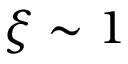Convert formula to latex. <formula><loc_0><loc_0><loc_500><loc_500>\xi \sim 1</formula> 